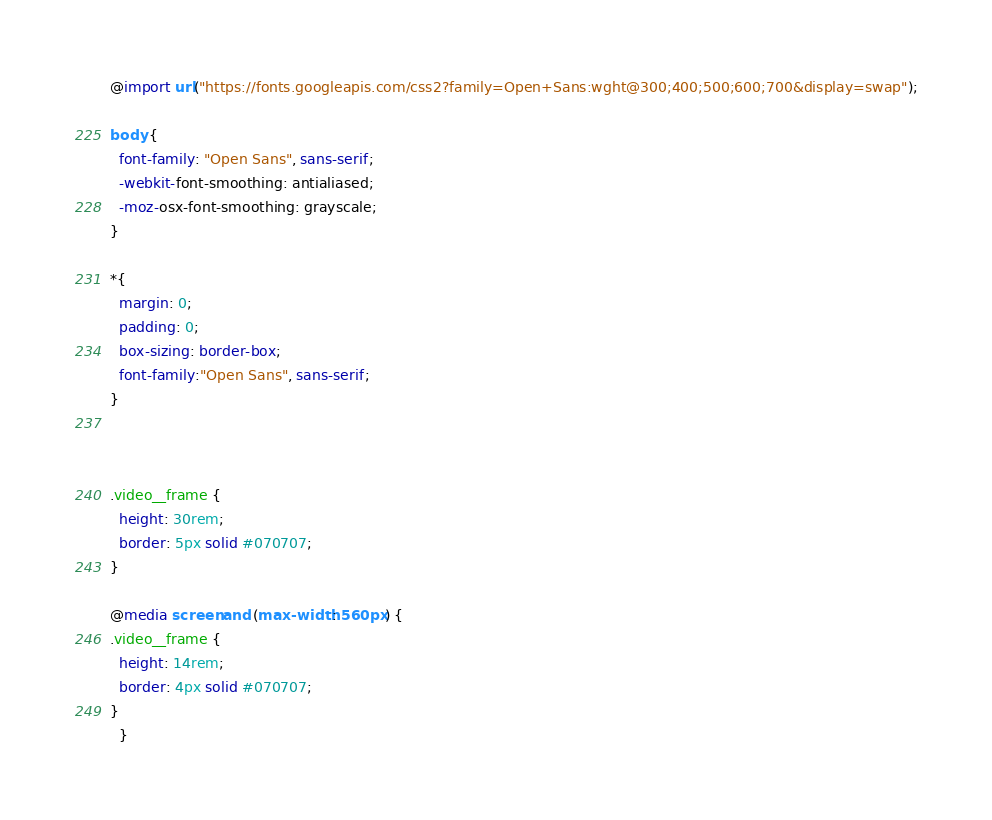<code> <loc_0><loc_0><loc_500><loc_500><_CSS_>@import url("https://fonts.googleapis.com/css2?family=Open+Sans:wght@300;400;500;600;700&display=swap");

body {
  font-family: "Open Sans", sans-serif;
  -webkit-font-smoothing: antialiased;
  -moz-osx-font-smoothing: grayscale;
}

*{
  margin: 0;
  padding: 0;
  box-sizing: border-box;
  font-family:"Open Sans", sans-serif;
}



.video__frame {
  height: 30rem;
  border: 5px solid #070707;
}

@media screen and (max-width: 560px) {
.video__frame {
  height: 14rem;
  border: 4px solid #070707;
}
  }
</code> 